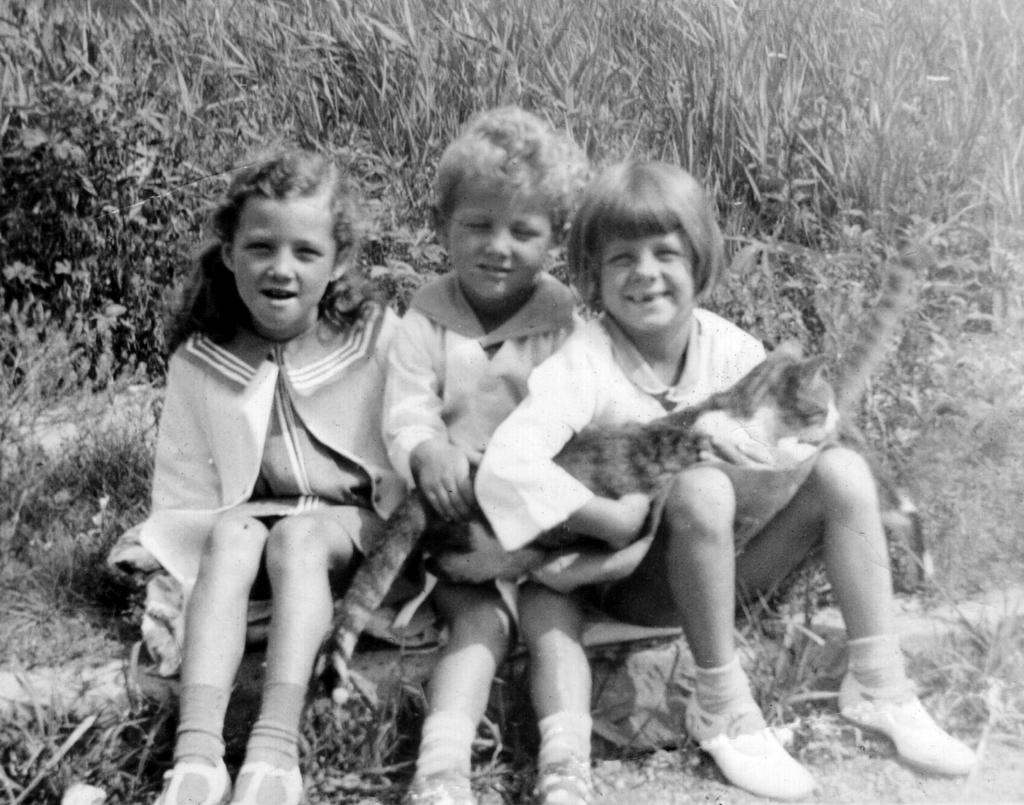How many individuals are present in the image? There are three people in the picture. What other living creature can be seen in the image? There is a cat in the picture. What type of vegetation is visible behind the people? There is grass visible behind the people. What type of seat is the cat using in the image? There is no seat present in the image, and the cat is not using any seat. Is the cat wearing a skate in the image? There is no skate present in the image, and the cat is not wearing any skate. 